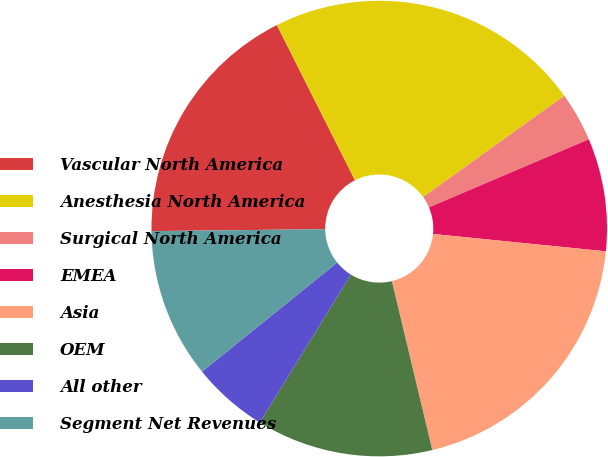<chart> <loc_0><loc_0><loc_500><loc_500><pie_chart><fcel>Vascular North America<fcel>Anesthesia North America<fcel>Surgical North America<fcel>EMEA<fcel>Asia<fcel>OEM<fcel>All other<fcel>Segment Net Revenues<nl><fcel>17.76%<fcel>22.51%<fcel>3.5%<fcel>8.0%<fcel>19.66%<fcel>12.53%<fcel>5.4%<fcel>10.63%<nl></chart> 